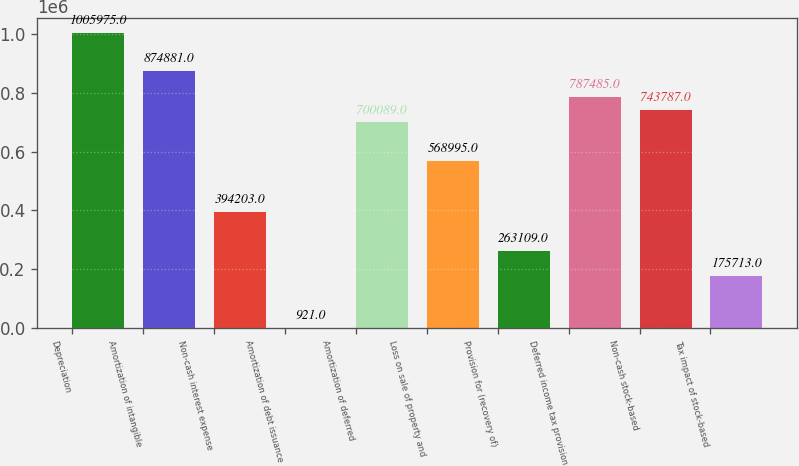<chart> <loc_0><loc_0><loc_500><loc_500><bar_chart><fcel>Depreciation<fcel>Amortization of intangible<fcel>Non-cash interest expense<fcel>Amortization of debt issuance<fcel>Amortization of deferred<fcel>Loss on sale of property and<fcel>Provision for (recovery of)<fcel>Deferred income tax provision<fcel>Non-cash stock-based<fcel>Tax impact of stock-based<nl><fcel>1.00598e+06<fcel>874881<fcel>394203<fcel>921<fcel>700089<fcel>568995<fcel>263109<fcel>787485<fcel>743787<fcel>175713<nl></chart> 